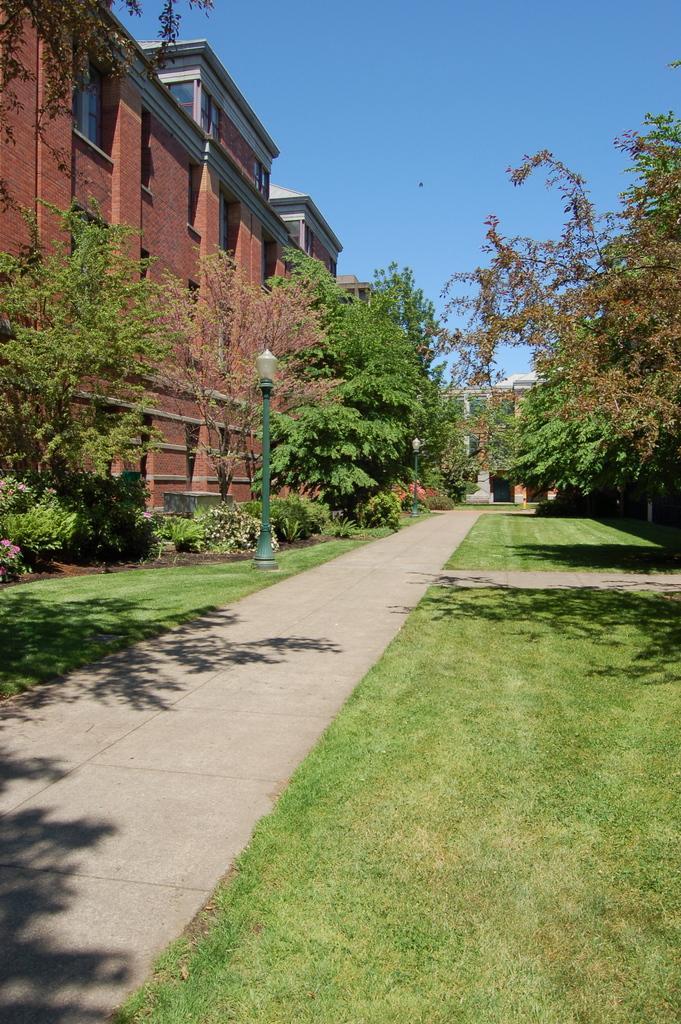In one or two sentences, can you explain what this image depicts? In this picture there is a way and there is greenery ground and few trees on either sides of it and there is a light attached to a pole and a building in the left corner and there is another building in the background. 